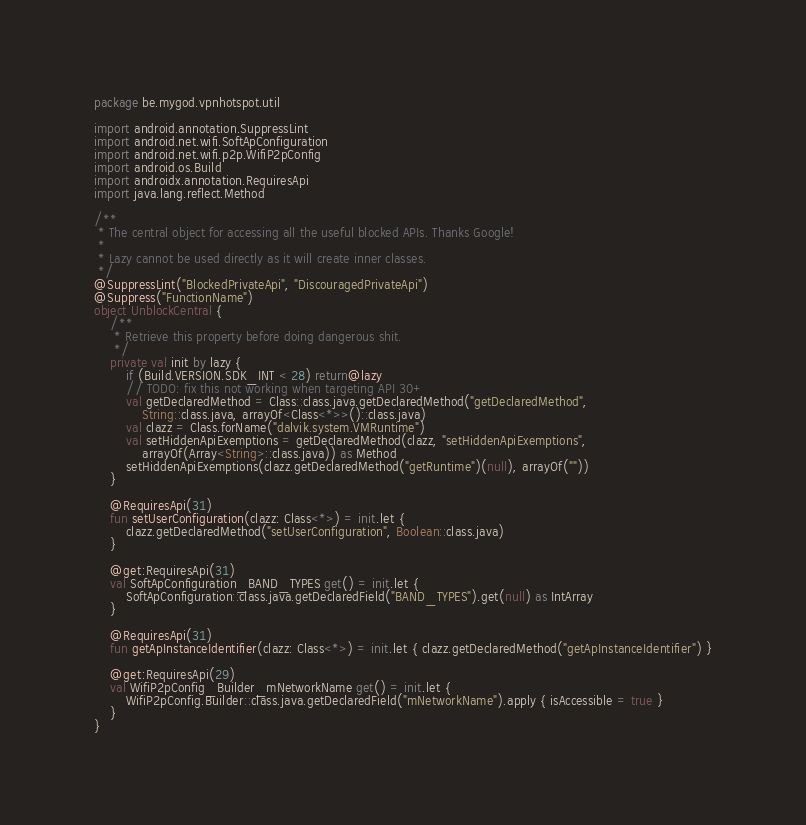<code> <loc_0><loc_0><loc_500><loc_500><_Kotlin_>package be.mygod.vpnhotspot.util

import android.annotation.SuppressLint
import android.net.wifi.SoftApConfiguration
import android.net.wifi.p2p.WifiP2pConfig
import android.os.Build
import androidx.annotation.RequiresApi
import java.lang.reflect.Method

/**
 * The central object for accessing all the useful blocked APIs. Thanks Google!
 *
 * Lazy cannot be used directly as it will create inner classes.
 */
@SuppressLint("BlockedPrivateApi", "DiscouragedPrivateApi")
@Suppress("FunctionName")
object UnblockCentral {
    /**
     * Retrieve this property before doing dangerous shit.
     */
    private val init by lazy {
        if (Build.VERSION.SDK_INT < 28) return@lazy
        // TODO: fix this not working when targeting API 30+
        val getDeclaredMethod = Class::class.java.getDeclaredMethod("getDeclaredMethod",
            String::class.java, arrayOf<Class<*>>()::class.java)
        val clazz = Class.forName("dalvik.system.VMRuntime")
        val setHiddenApiExemptions = getDeclaredMethod(clazz, "setHiddenApiExemptions",
            arrayOf(Array<String>::class.java)) as Method
        setHiddenApiExemptions(clazz.getDeclaredMethod("getRuntime")(null), arrayOf(""))
    }

    @RequiresApi(31)
    fun setUserConfiguration(clazz: Class<*>) = init.let {
        clazz.getDeclaredMethod("setUserConfiguration", Boolean::class.java)
    }

    @get:RequiresApi(31)
    val SoftApConfiguration_BAND_TYPES get() = init.let {
        SoftApConfiguration::class.java.getDeclaredField("BAND_TYPES").get(null) as IntArray
    }

    @RequiresApi(31)
    fun getApInstanceIdentifier(clazz: Class<*>) = init.let { clazz.getDeclaredMethod("getApInstanceIdentifier") }

    @get:RequiresApi(29)
    val WifiP2pConfig_Builder_mNetworkName get() = init.let {
        WifiP2pConfig.Builder::class.java.getDeclaredField("mNetworkName").apply { isAccessible = true }
    }
}
</code> 